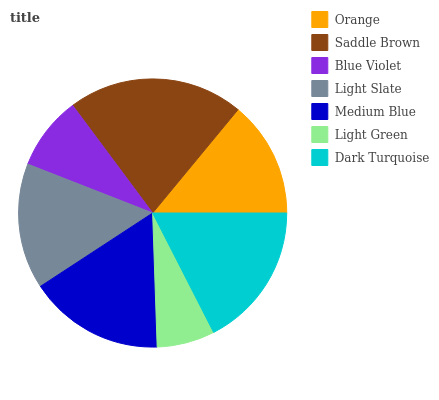Is Light Green the minimum?
Answer yes or no. Yes. Is Saddle Brown the maximum?
Answer yes or no. Yes. Is Blue Violet the minimum?
Answer yes or no. No. Is Blue Violet the maximum?
Answer yes or no. No. Is Saddle Brown greater than Blue Violet?
Answer yes or no. Yes. Is Blue Violet less than Saddle Brown?
Answer yes or no. Yes. Is Blue Violet greater than Saddle Brown?
Answer yes or no. No. Is Saddle Brown less than Blue Violet?
Answer yes or no. No. Is Light Slate the high median?
Answer yes or no. Yes. Is Light Slate the low median?
Answer yes or no. Yes. Is Saddle Brown the high median?
Answer yes or no. No. Is Dark Turquoise the low median?
Answer yes or no. No. 